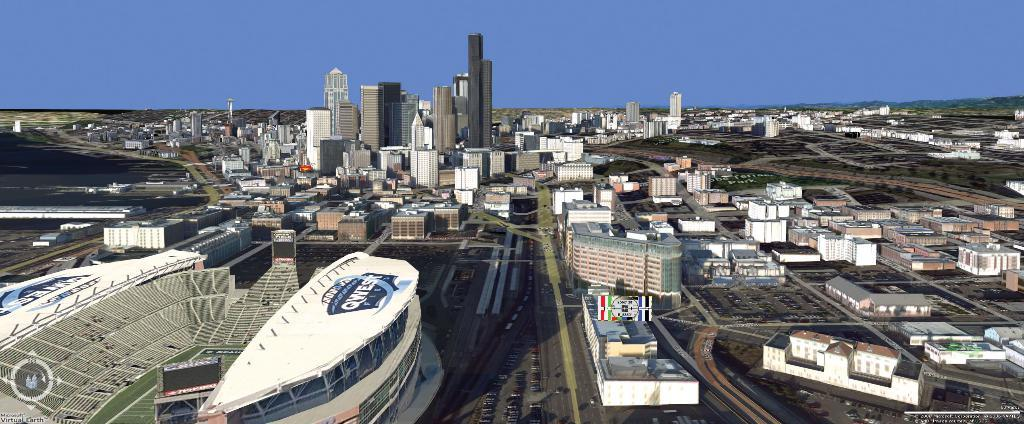What type of structures can be seen in the image? There are buildings in the image. What else can be seen in the image besides buildings? There are trees and vehicles on the road in the image. Where are the people in the image located? The people are in a stadium in the image. What type of fuel is being used by the woman in the image? There is no woman present in the image, and therefore no fuel usage can be observed. 